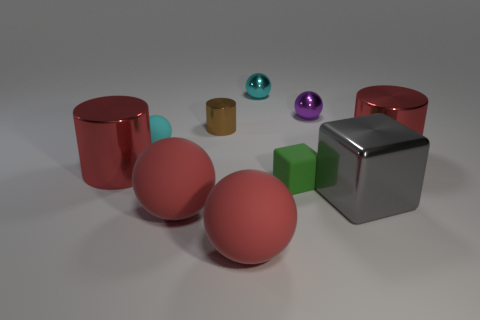How many other objects are there of the same color as the small rubber block?
Ensure brevity in your answer.  0. What number of cylinders are either purple metallic things or small brown shiny things?
Ensure brevity in your answer.  1. The large cylinder that is left of the cube that is behind the gray thing is what color?
Make the answer very short. Red. The purple object has what shape?
Ensure brevity in your answer.  Sphere. Is the size of the cyan object behind the brown cylinder the same as the green matte cube?
Provide a succinct answer. Yes. Are there any spheres that have the same material as the tiny purple object?
Your answer should be compact. Yes. How many objects are large red cylinders that are to the right of the large gray object or cubes?
Ensure brevity in your answer.  3. Is there a large red rubber thing?
Keep it short and to the point. Yes. There is a small thing that is in front of the brown shiny object and behind the small block; what shape is it?
Your response must be concise. Sphere. There is a red shiny object to the right of the small matte ball; what size is it?
Your answer should be very brief. Large. 